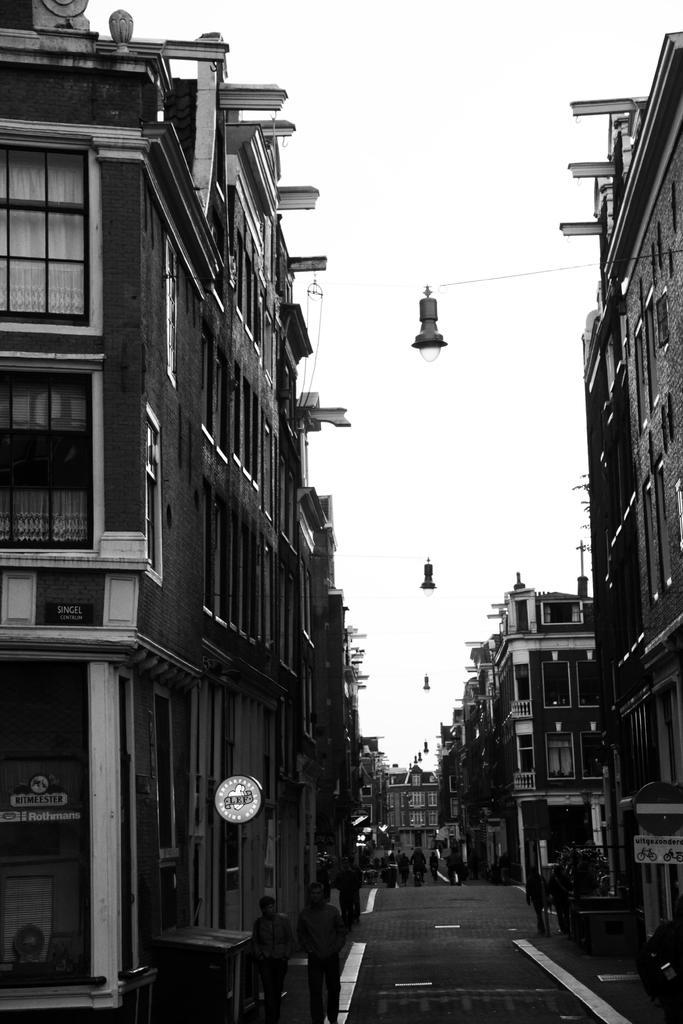Can you describe this image briefly? This picture is clicked outside the city. Here, we see many people walking on the road and on either side of the road, there are buildings. Beside the building, we see a caution board. At the top of the picture, we see the sky and the street lights. This is a black and white picture. 